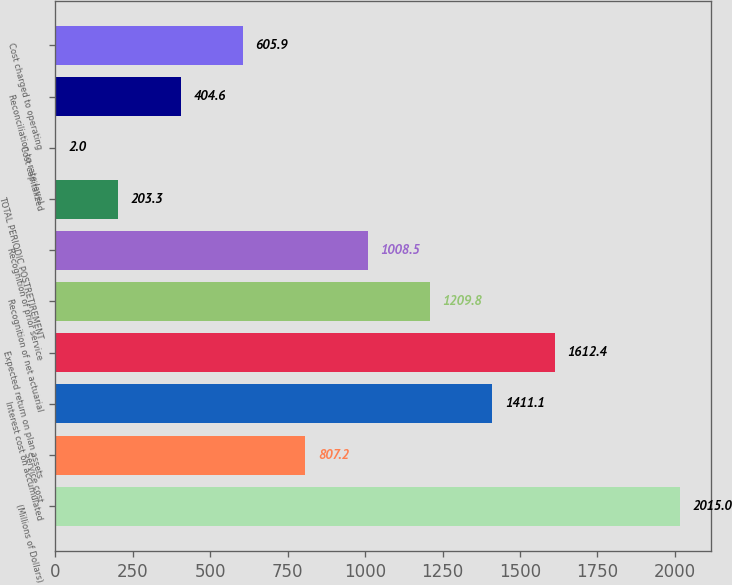Convert chart to OTSL. <chart><loc_0><loc_0><loc_500><loc_500><bar_chart><fcel>(Millions of Dollars)<fcel>Service cost<fcel>Interest cost on accumulated<fcel>Expected return on plan assets<fcel>Recognition of net actuarial<fcel>Recognition of prior service<fcel>TOTAL PERIODIC POSTRETIREMENT<fcel>Cost capitalized<fcel>Reconciliation to rate level<fcel>Cost charged to operating<nl><fcel>2015<fcel>807.2<fcel>1411.1<fcel>1612.4<fcel>1209.8<fcel>1008.5<fcel>203.3<fcel>2<fcel>404.6<fcel>605.9<nl></chart> 